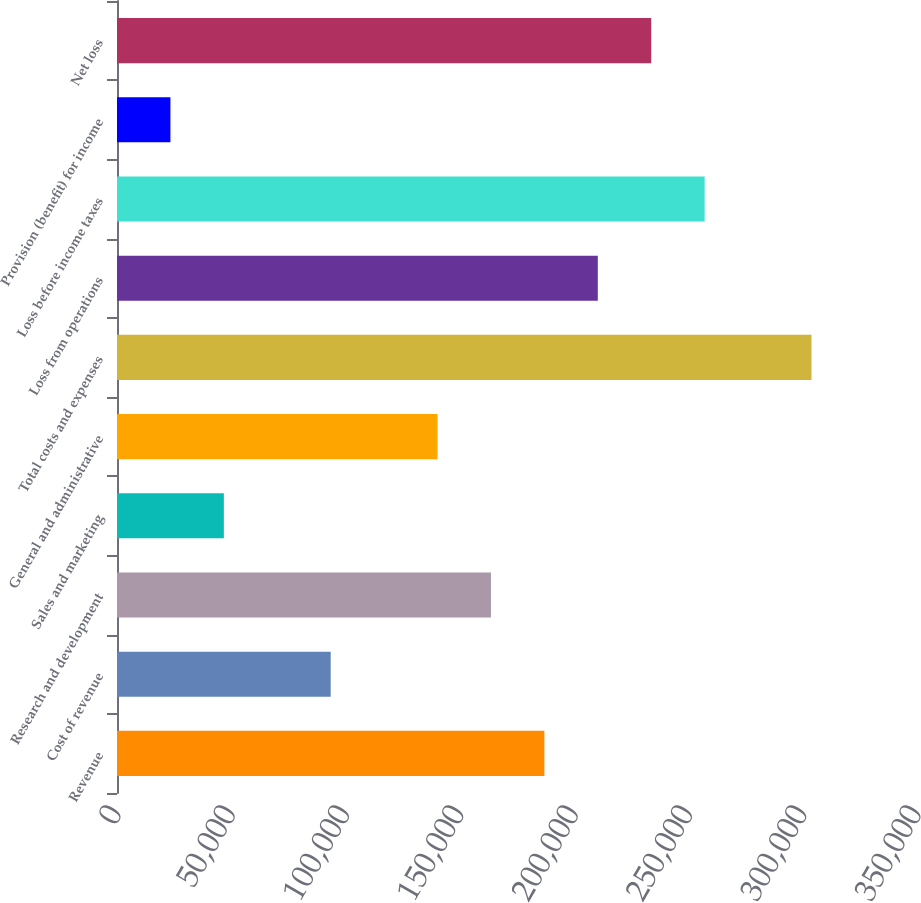<chart> <loc_0><loc_0><loc_500><loc_500><bar_chart><fcel>Revenue<fcel>Cost of revenue<fcel>Research and development<fcel>Sales and marketing<fcel>General and administrative<fcel>Total costs and expenses<fcel>Loss from operations<fcel>Loss before income taxes<fcel>Provision (benefit) for income<fcel>Net loss<nl><fcel>186980<fcel>93490.6<fcel>163607<fcel>46746.1<fcel>140235<fcel>303841<fcel>210352<fcel>257096<fcel>23373.8<fcel>233724<nl></chart> 